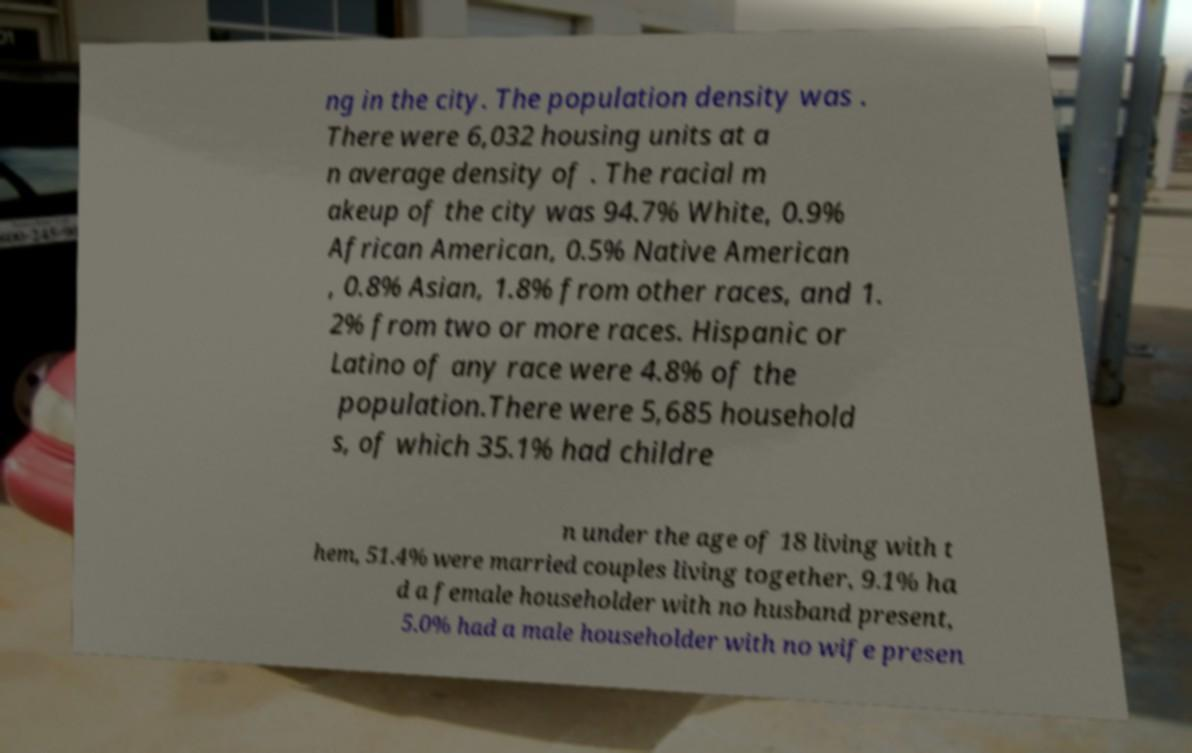What messages or text are displayed in this image? I need them in a readable, typed format. ng in the city. The population density was . There were 6,032 housing units at a n average density of . The racial m akeup of the city was 94.7% White, 0.9% African American, 0.5% Native American , 0.8% Asian, 1.8% from other races, and 1. 2% from two or more races. Hispanic or Latino of any race were 4.8% of the population.There were 5,685 household s, of which 35.1% had childre n under the age of 18 living with t hem, 51.4% were married couples living together, 9.1% ha d a female householder with no husband present, 5.0% had a male householder with no wife presen 